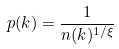Convert formula to latex. <formula><loc_0><loc_0><loc_500><loc_500>p ( k ) = \frac { 1 } { n ( k ) ^ { 1 / \xi } }</formula> 